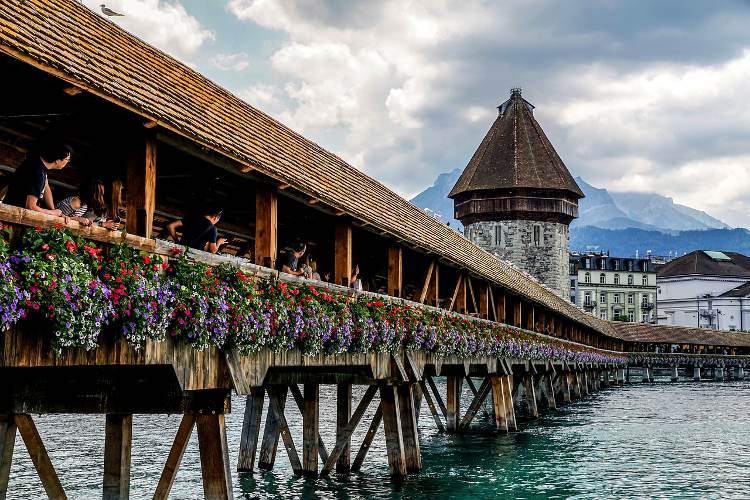Suppose a magical event happened here. Describe it. Imagine as the sun sets over Lucerne, a soft, golden glow envelops the Chapel Bridge. Suddenly, a ripple of luminescent light flows along the wooden beams, and the flowers begin to sparkle with ethereal hues. The Water Tower shimmers with an otherworldly glow, and from the river below, a mist rises, forming shapes and figures that dance in a graceful waltz along the water's edge. As night fully descends, the bridge becomes a conduit of magic, where anyone who steps on it experiences moments from the past and future, seeing visions of medieval knights, bustling merchant days, and future festivals yet to come. The air hums with enchantment, and for a brief time, the Chapel Bridge is not just a passage over water but a passage through time and imagination.  Describe how the bridge might look during a winter festival. During a winter festival, the Chapel Bridge transforms into a winter wonderland. The wooden structure is adorned with twinkling fairy lights, casting a warm, inviting glow against the cool winter air. Snow delicately blankets the bridge's roof and the flower boxes, now filled with evergreen branches festooned with ornaments and red bows. The Water Tower stands encased in festive lights, its reflection shimmering in the icy river below. Stalls line the sides of the bridge, offering hot cocoa, mulled wine, and warm pastries, creating an aroma that entices passersby. The sounds of cheerful holiday music and the cheerful laughter of families and friends fill the air, as the bridge becomes a central hub of celebration and festive spirit. 